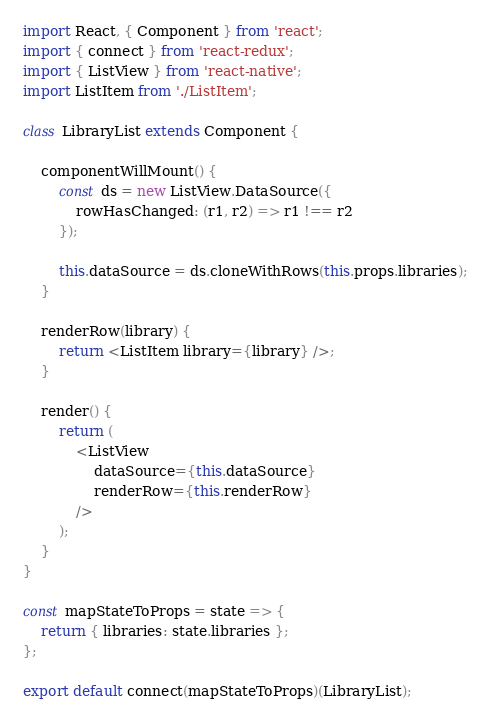Convert code to text. <code><loc_0><loc_0><loc_500><loc_500><_JavaScript_>import React, { Component } from 'react';
import { connect } from 'react-redux';
import { ListView } from 'react-native';
import ListItem from './ListItem';

class LibraryList extends Component {

    componentWillMount() {
        const ds = new ListView.DataSource({
            rowHasChanged: (r1, r2) => r1 !== r2
        });

        this.dataSource = ds.cloneWithRows(this.props.libraries);
    }

    renderRow(library) {
        return <ListItem library={library} />;
    }

    render() {
        return (
            <ListView
                dataSource={this.dataSource}
                renderRow={this.renderRow}
            />
        );
    }
}

const mapStateToProps = state => {
    return { libraries: state.libraries };
};

export default connect(mapStateToProps)(LibraryList);
</code> 